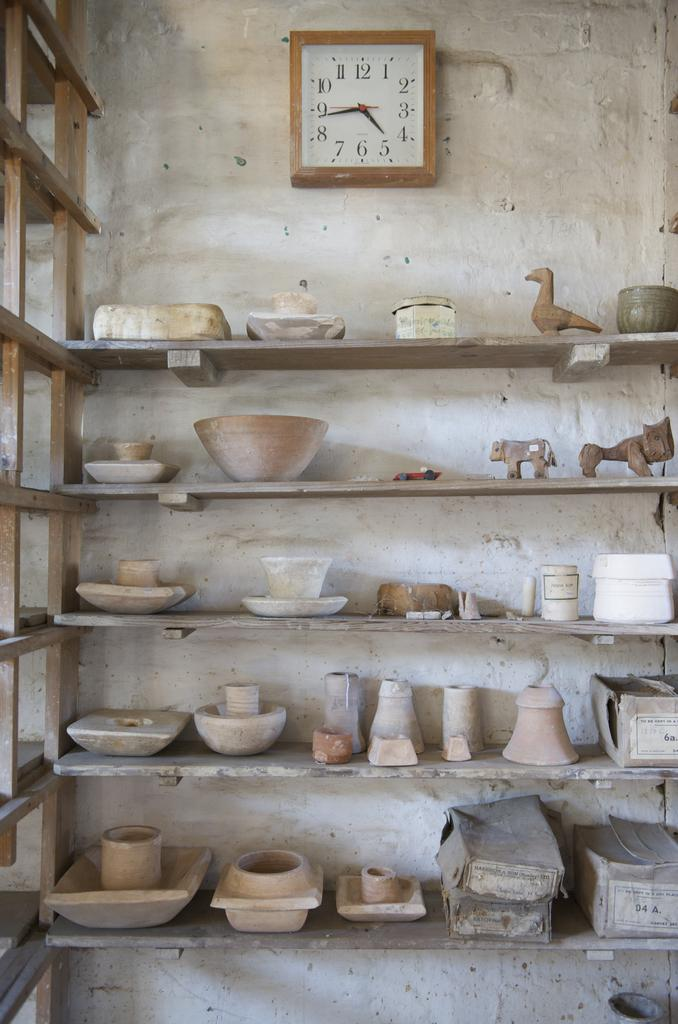<image>
Relay a brief, clear account of the picture shown. The clock above the shelf full of pottery reads 4:42. 